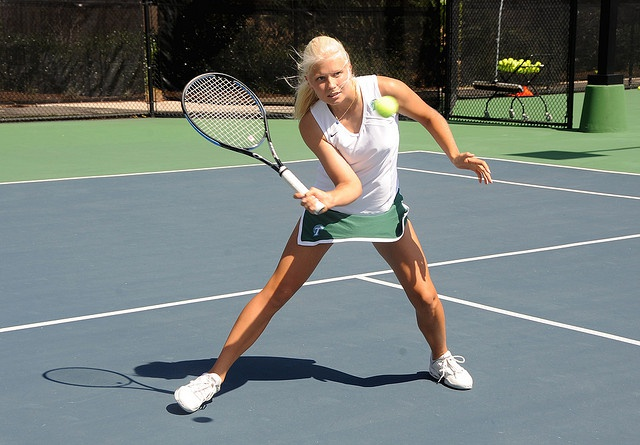Describe the objects in this image and their specific colors. I can see people in black, white, darkgray, and maroon tones, tennis racket in black, ivory, darkgray, and olive tones, sports ball in black, lightyellow, khaki, and olive tones, sports ball in black, olive, and yellow tones, and sports ball in black, yellow, khaki, and darkgreen tones in this image. 